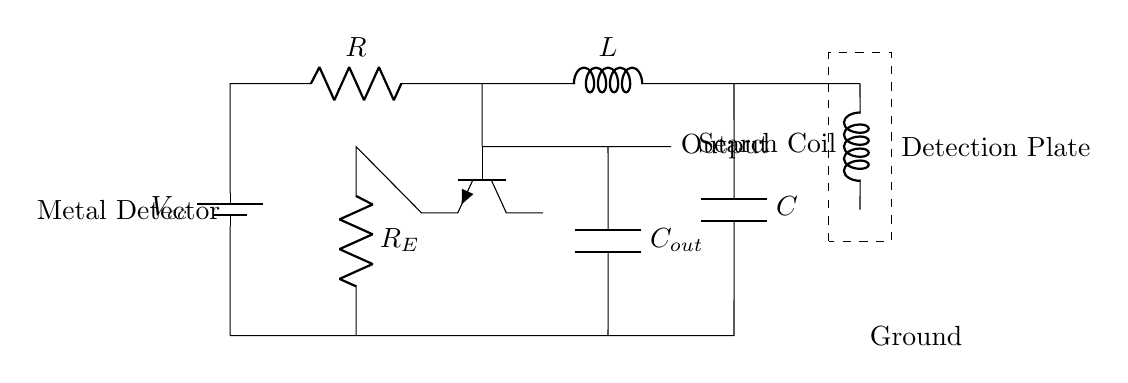What is the voltage source in this circuit? The voltage source is labeled as Vcc, which provides the necessary voltage for the circuit to operate.
Answer: Vcc What components make up this circuit? The circuit consists of a resistor, an inductor, a capacitor, a transistor, and a search coil. These components are connected in a specific arrangement to create an oscillator circuit.
Answer: Resistor, Inductor, Capacitor, Transistor, Search Coil What is the purpose of the search coil in this circuit? The search coil acts as an inductive sensor to detect metal objects. When metal is near the coil, it affects the oscillation frequency, indicating the presence of metal.
Answer: Inductive sensor What role does the capacitor play in the RLC circuit? The capacitor provides a reactive component to the circuit, storing and releasing energy, which helps establish the oscillation frequency alongside the inductor.
Answer: Energy storage and releasing How does the presence of metal affect the circuit? When metal is detected, it alters the inductance in the circuit, affecting the oscillation frequency, which can be measured through the output. This change indicates the presence of metal.
Answer: Alters inductance and frequency What is the output of this circuit used for? The output signal is used to indicate the presence of metal, typically connected to a speaker or LED that signals detection.
Answer: Indicate metal presence 